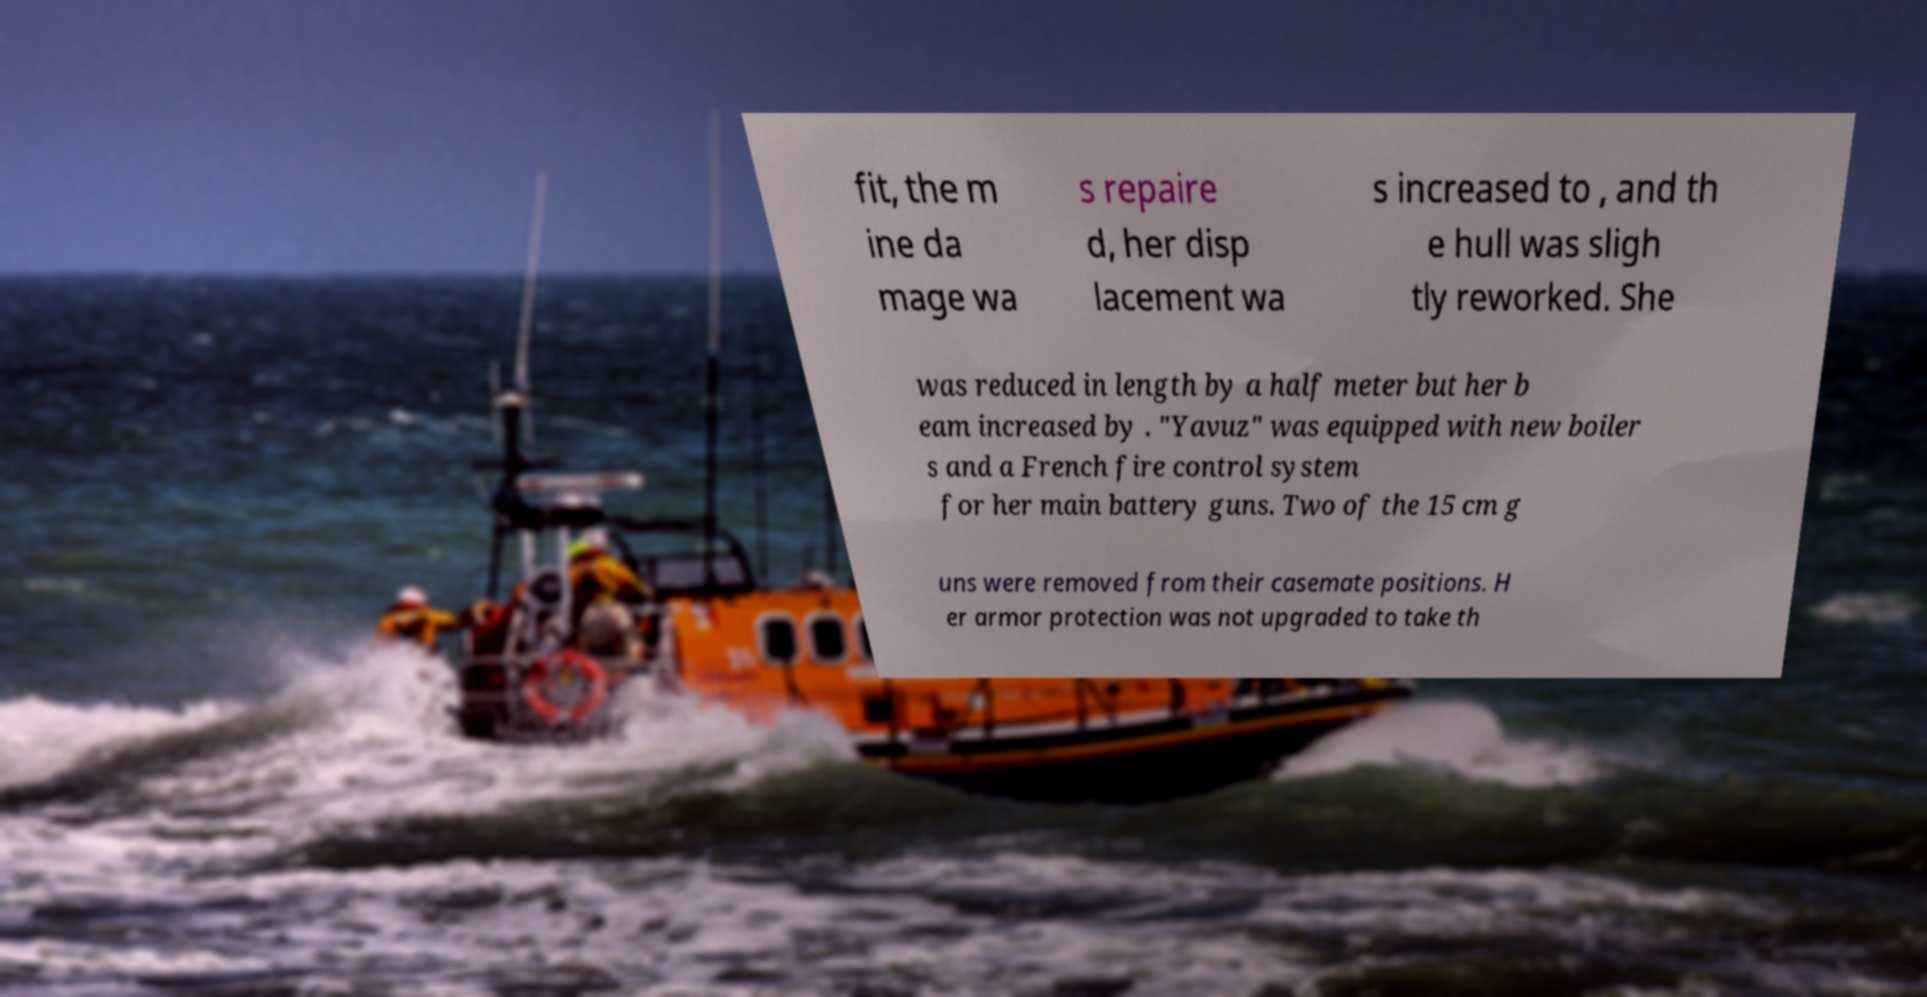There's text embedded in this image that I need extracted. Can you transcribe it verbatim? fit, the m ine da mage wa s repaire d, her disp lacement wa s increased to , and th e hull was sligh tly reworked. She was reduced in length by a half meter but her b eam increased by . "Yavuz" was equipped with new boiler s and a French fire control system for her main battery guns. Two of the 15 cm g uns were removed from their casemate positions. H er armor protection was not upgraded to take th 